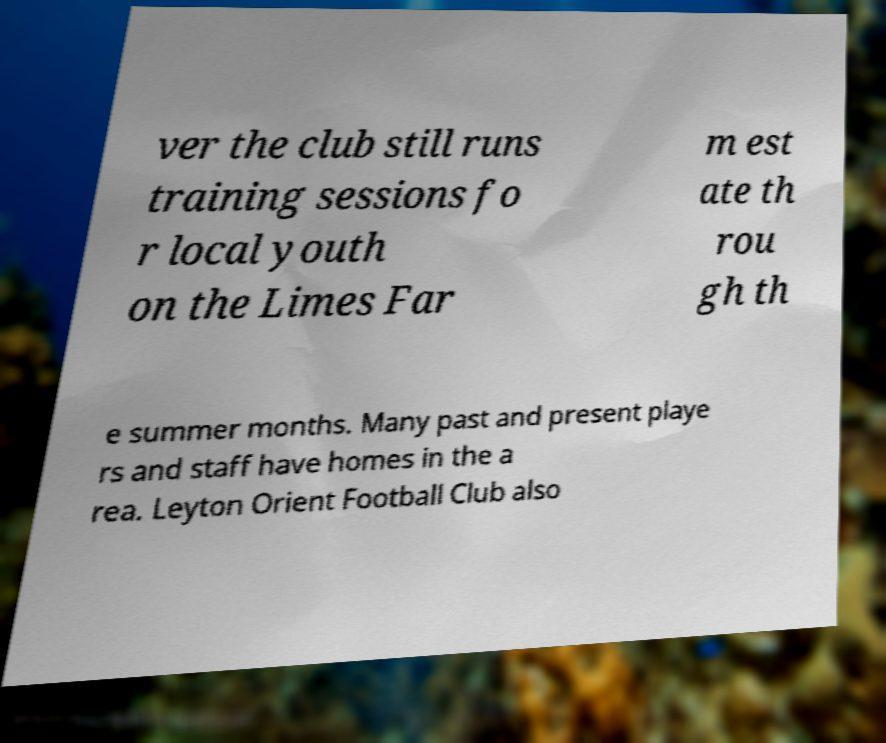Please identify and transcribe the text found in this image. ver the club still runs training sessions fo r local youth on the Limes Far m est ate th rou gh th e summer months. Many past and present playe rs and staff have homes in the a rea. Leyton Orient Football Club also 